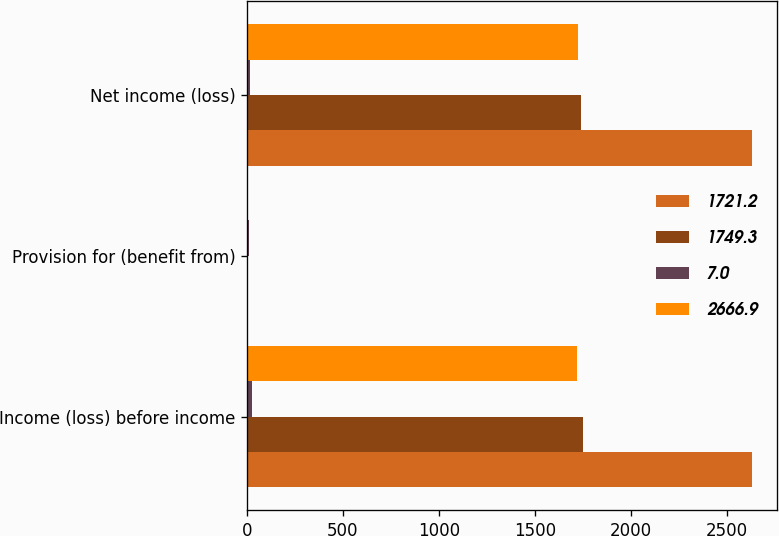Convert chart. <chart><loc_0><loc_0><loc_500><loc_500><stacked_bar_chart><ecel><fcel>Income (loss) before income<fcel>Provision for (benefit from)<fcel>Net income (loss)<nl><fcel>1721.2<fcel>2631.8<fcel>1.8<fcel>2633.6<nl><fcel>1749.3<fcel>1749.3<fcel>5.8<fcel>1743.5<nl><fcel>7<fcel>28.1<fcel>10.6<fcel>17.5<nl><fcel>2666.9<fcel>1721.2<fcel>4.8<fcel>1726<nl></chart> 